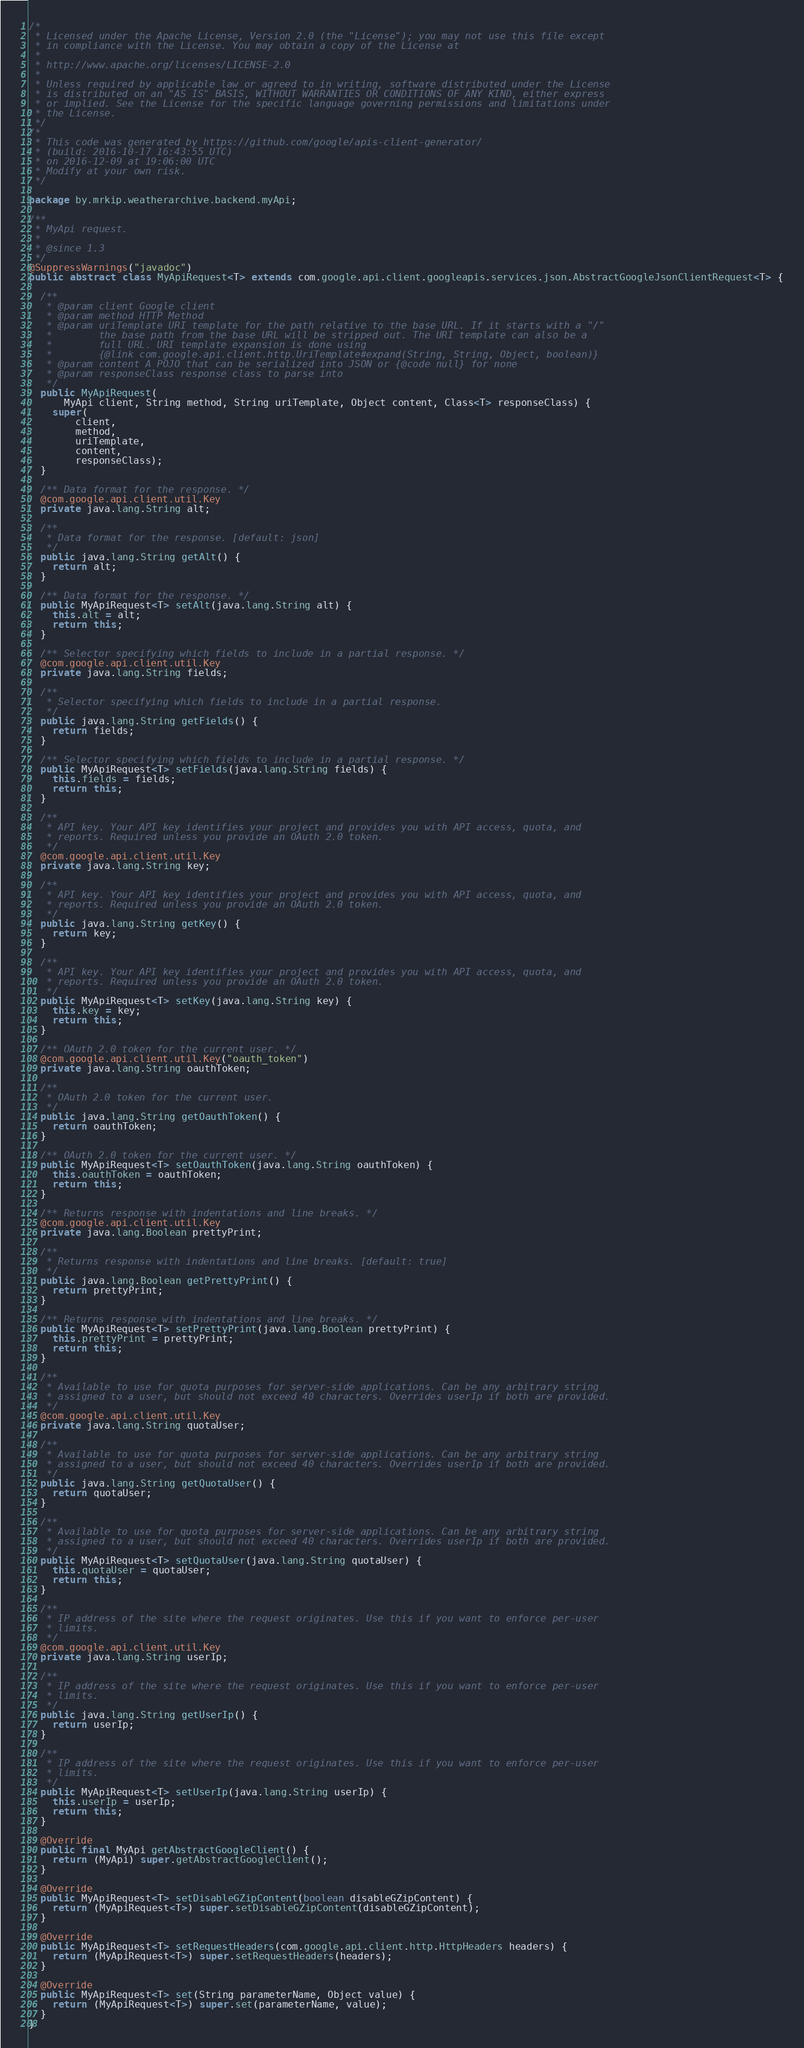Convert code to text. <code><loc_0><loc_0><loc_500><loc_500><_Java_>/*
 * Licensed under the Apache License, Version 2.0 (the "License"); you may not use this file except
 * in compliance with the License. You may obtain a copy of the License at
 *
 * http://www.apache.org/licenses/LICENSE-2.0
 *
 * Unless required by applicable law or agreed to in writing, software distributed under the License
 * is distributed on an "AS IS" BASIS, WITHOUT WARRANTIES OR CONDITIONS OF ANY KIND, either express
 * or implied. See the License for the specific language governing permissions and limitations under
 * the License.
 */
/*
 * This code was generated by https://github.com/google/apis-client-generator/
 * (build: 2016-10-17 16:43:55 UTC)
 * on 2016-12-09 at 19:06:00 UTC 
 * Modify at your own risk.
 */

package by.mrkip.weatherarchive.backend.myApi;

/**
 * MyApi request.
 *
 * @since 1.3
 */
@SuppressWarnings("javadoc")
public abstract class MyApiRequest<T> extends com.google.api.client.googleapis.services.json.AbstractGoogleJsonClientRequest<T> {

  /**
   * @param client Google client
   * @param method HTTP Method
   * @param uriTemplate URI template for the path relative to the base URL. If it starts with a "/"
   *        the base path from the base URL will be stripped out. The URI template can also be a
   *        full URL. URI template expansion is done using
   *        {@link com.google.api.client.http.UriTemplate#expand(String, String, Object, boolean)}
   * @param content A POJO that can be serialized into JSON or {@code null} for none
   * @param responseClass response class to parse into
   */
  public MyApiRequest(
      MyApi client, String method, String uriTemplate, Object content, Class<T> responseClass) {
    super(
        client,
        method,
        uriTemplate,
        content,
        responseClass);
  }

  /** Data format for the response. */
  @com.google.api.client.util.Key
  private java.lang.String alt;

  /**
   * Data format for the response. [default: json]
   */
  public java.lang.String getAlt() {
    return alt;
  }

  /** Data format for the response. */
  public MyApiRequest<T> setAlt(java.lang.String alt) {
    this.alt = alt;
    return this;
  }

  /** Selector specifying which fields to include in a partial response. */
  @com.google.api.client.util.Key
  private java.lang.String fields;

  /**
   * Selector specifying which fields to include in a partial response.
   */
  public java.lang.String getFields() {
    return fields;
  }

  /** Selector specifying which fields to include in a partial response. */
  public MyApiRequest<T> setFields(java.lang.String fields) {
    this.fields = fields;
    return this;
  }

  /**
   * API key. Your API key identifies your project and provides you with API access, quota, and
   * reports. Required unless you provide an OAuth 2.0 token.
   */
  @com.google.api.client.util.Key
  private java.lang.String key;

  /**
   * API key. Your API key identifies your project and provides you with API access, quota, and
   * reports. Required unless you provide an OAuth 2.0 token.
   */
  public java.lang.String getKey() {
    return key;
  }

  /**
   * API key. Your API key identifies your project and provides you with API access, quota, and
   * reports. Required unless you provide an OAuth 2.0 token.
   */
  public MyApiRequest<T> setKey(java.lang.String key) {
    this.key = key;
    return this;
  }

  /** OAuth 2.0 token for the current user. */
  @com.google.api.client.util.Key("oauth_token")
  private java.lang.String oauthToken;

  /**
   * OAuth 2.0 token for the current user.
   */
  public java.lang.String getOauthToken() {
    return oauthToken;
  }

  /** OAuth 2.0 token for the current user. */
  public MyApiRequest<T> setOauthToken(java.lang.String oauthToken) {
    this.oauthToken = oauthToken;
    return this;
  }

  /** Returns response with indentations and line breaks. */
  @com.google.api.client.util.Key
  private java.lang.Boolean prettyPrint;

  /**
   * Returns response with indentations and line breaks. [default: true]
   */
  public java.lang.Boolean getPrettyPrint() {
    return prettyPrint;
  }

  /** Returns response with indentations and line breaks. */
  public MyApiRequest<T> setPrettyPrint(java.lang.Boolean prettyPrint) {
    this.prettyPrint = prettyPrint;
    return this;
  }

  /**
   * Available to use for quota purposes for server-side applications. Can be any arbitrary string
   * assigned to a user, but should not exceed 40 characters. Overrides userIp if both are provided.
   */
  @com.google.api.client.util.Key
  private java.lang.String quotaUser;

  /**
   * Available to use for quota purposes for server-side applications. Can be any arbitrary string
   * assigned to a user, but should not exceed 40 characters. Overrides userIp if both are provided.
   */
  public java.lang.String getQuotaUser() {
    return quotaUser;
  }

  /**
   * Available to use for quota purposes for server-side applications. Can be any arbitrary string
   * assigned to a user, but should not exceed 40 characters. Overrides userIp if both are provided.
   */
  public MyApiRequest<T> setQuotaUser(java.lang.String quotaUser) {
    this.quotaUser = quotaUser;
    return this;
  }

  /**
   * IP address of the site where the request originates. Use this if you want to enforce per-user
   * limits.
   */
  @com.google.api.client.util.Key
  private java.lang.String userIp;

  /**
   * IP address of the site where the request originates. Use this if you want to enforce per-user
   * limits.
   */
  public java.lang.String getUserIp() {
    return userIp;
  }

  /**
   * IP address of the site where the request originates. Use this if you want to enforce per-user
   * limits.
   */
  public MyApiRequest<T> setUserIp(java.lang.String userIp) {
    this.userIp = userIp;
    return this;
  }

  @Override
  public final MyApi getAbstractGoogleClient() {
    return (MyApi) super.getAbstractGoogleClient();
  }

  @Override
  public MyApiRequest<T> setDisableGZipContent(boolean disableGZipContent) {
    return (MyApiRequest<T>) super.setDisableGZipContent(disableGZipContent);
  }

  @Override
  public MyApiRequest<T> setRequestHeaders(com.google.api.client.http.HttpHeaders headers) {
    return (MyApiRequest<T>) super.setRequestHeaders(headers);
  }

  @Override
  public MyApiRequest<T> set(String parameterName, Object value) {
    return (MyApiRequest<T>) super.set(parameterName, value);
  }
}
</code> 